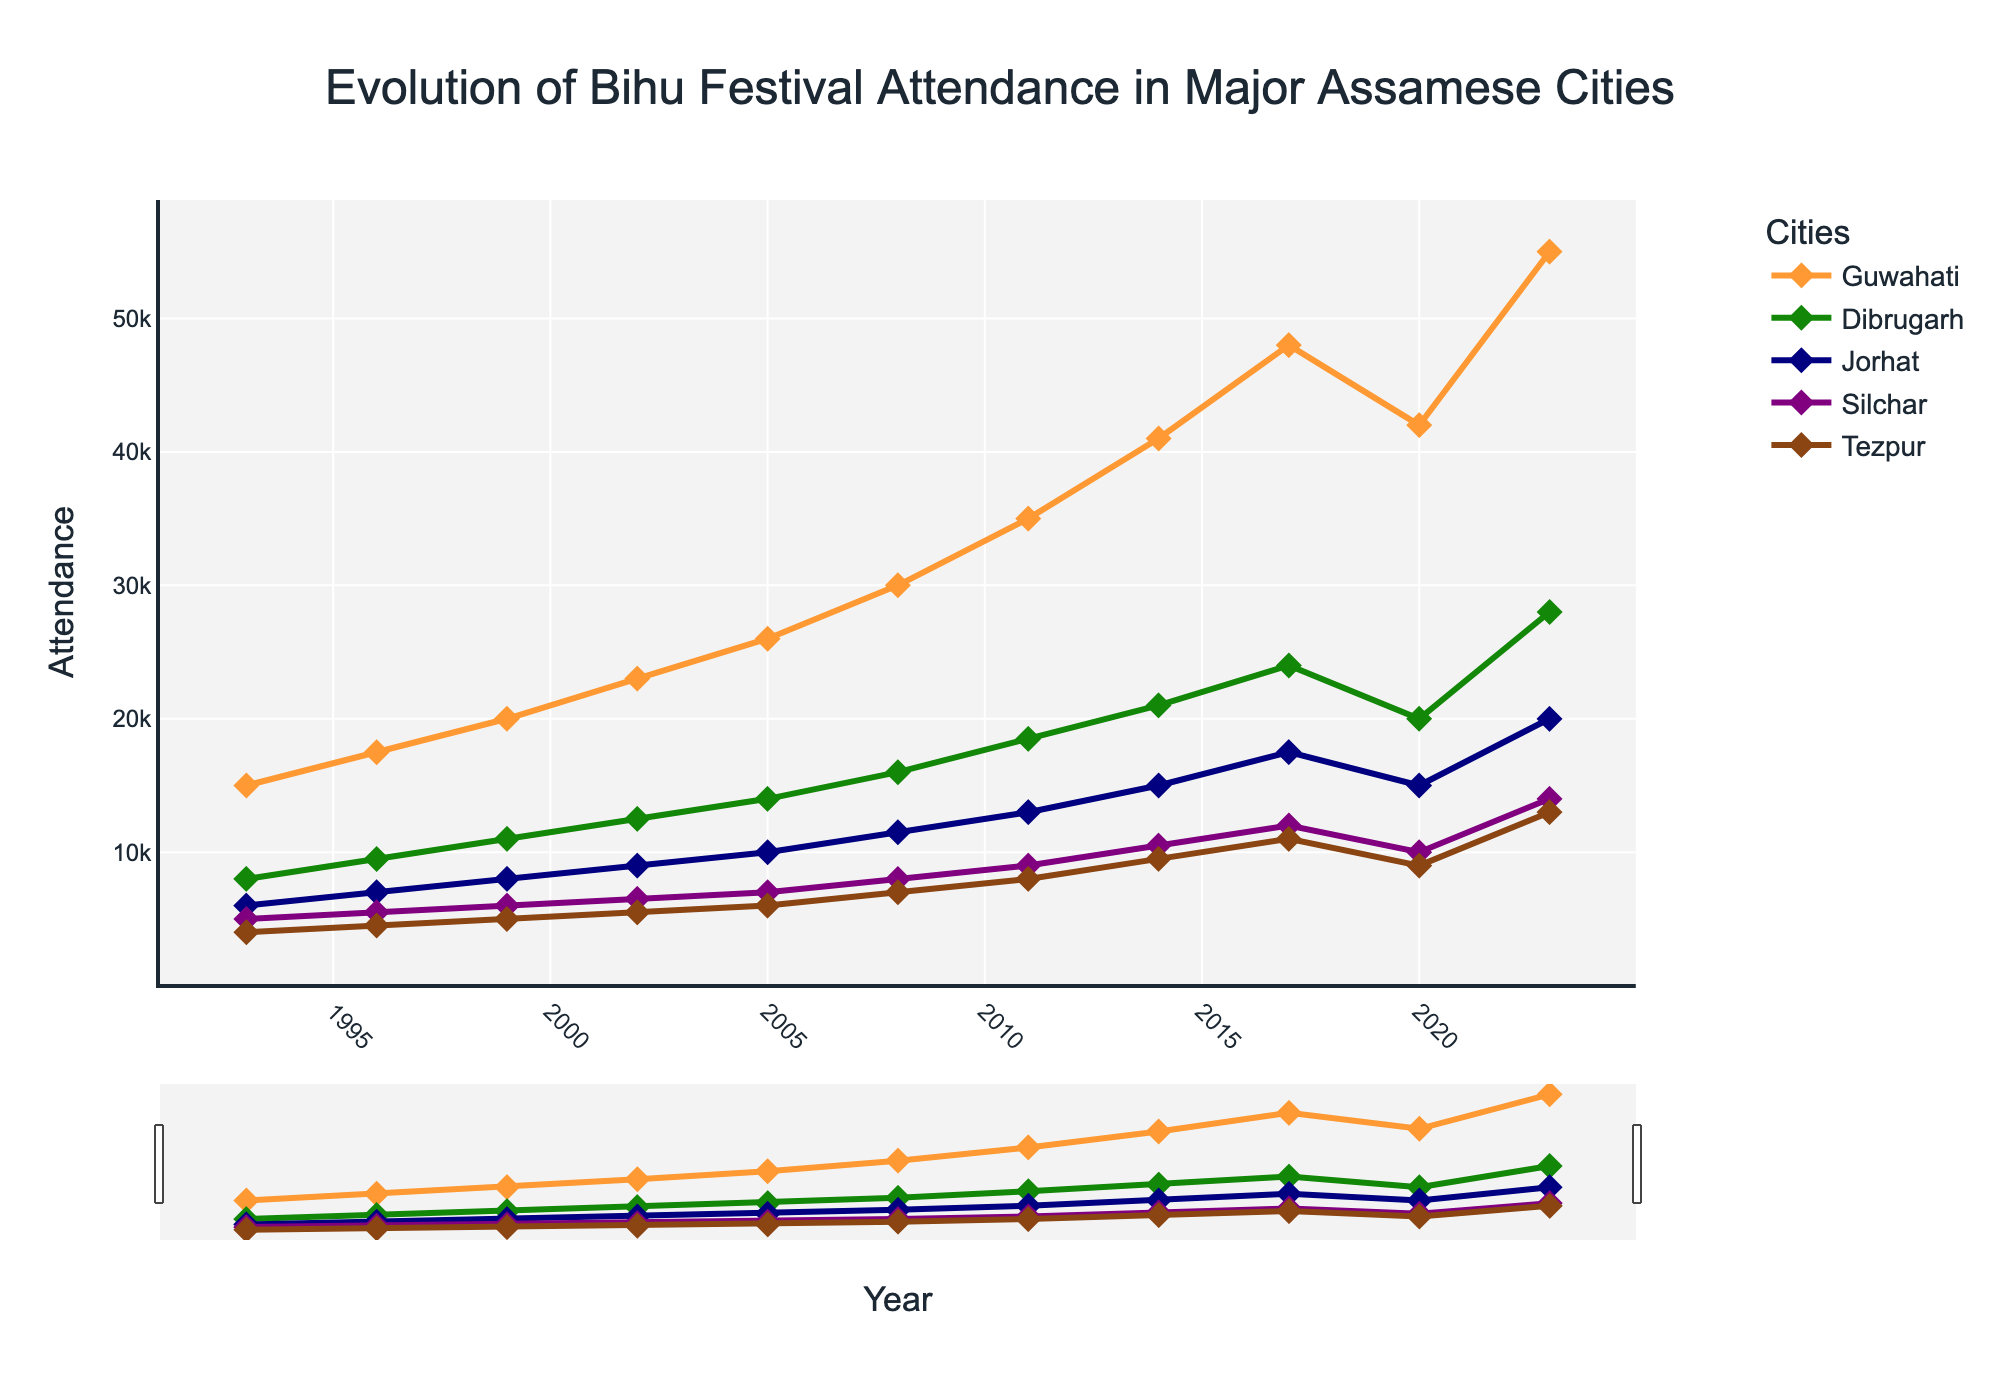Which city had the highest Bihu festival attendance in 2023? The data for 2023 shows the following attendances: Guwahati (55,000), Dibrugarh (28,000), Jorhat (20,000), Silchar (14,000), Tezpur (13,000). Guwahati has the highest attendance.
Answer: Guwahati Which city's Bihu festival attendance grew the most between 1993 and 2023? To find the city with the most growth, calculate the difference in attendance from 1993 to 2023 for each city: Guwahati (55,000 - 15,000 = 40,000), Dibrugarh (28,000 - 8,000 = 20,000), Jorhat (20,000 - 6,000 = 14,000), Silchar (14,000 - 5,000 = 9,000), Tezpur (13,000 - 4,000 = 9,000). Guwahati shows the largest increase.
Answer: Guwahati Which city showed a decline in Bihu festival attendance between 2017 and 2020? Examine the attendance figures: Guwahati (48,000 in 2017 to 42,000 in 2020), Dibrugarh (24,000 to 20,000), Jorhat (17,500 to 15,000), Silchar (12,000 to 10,000), Tezpur (11,000 to 9,000). All cities show a decline, but Guwahati is an example.
Answer: All cities How many cities had more than 20,000 attendees in 2023? Attendance figures for 2023: Guwahati (55,000), Dibrugarh (28,000), Jorhat (20,000), Silchar (14,000), Tezpur (13,000). There are three cities (Guwahati, Dibrugarh, Jorhat) with more than 20,000 attendees.
Answer: 3 What is the average attendance across all cities in 2023? Add the 2023 attendance figures: 55,000 (Guwahati) + 28,000 (Dibrugarh) + 20,000 (Jorhat) + 14,000 (Silchar) + 13,000 (Tezpur) = 130,000. Divide by the number of cities (5): 130,000 / 5 = 26,000.
Answer: 26,000 Which city had a consistent increase in Bihu festival attendance from 1993 to 2017? Review attendance trends: Guwahati, Dibrugarh, Jorhat, Silchar, Tezpur each show consistent rises from 1993 through 2017. For example, Guwahati's numbers continuously rise from 15,000 (1993) to 48,000 (2017). Multiple cities comply.
Answer: Multiple cities In which year did Jorhat's attendance reach 10,000 for the first time? Looking at the data, Jorhat's attendance reached 10,000 in 2005.
Answer: 2005 By how much did Silchar's Bihu attendance increase between 1993 and 2023? Silchar's attendance in 1993 was 5,000 and in 2023 it was 14,000. The increase is 14,000 - 5,000 = 9,000.
Answer: 9,000 Which city experienced the lowest attendance drop from 2017 to 2020? Guwahati dropped from 48,000 (2017) to 42,000 (2020), Dibrugarh from 24,000 to 20,000, Jorhat from 17,500 to 15,000, Silchar from 12,000 to 10,000, and Tezpur from 11,000 to 9,000. Guwahati had the smallest drop (6,000).
Answer: Guwahati 